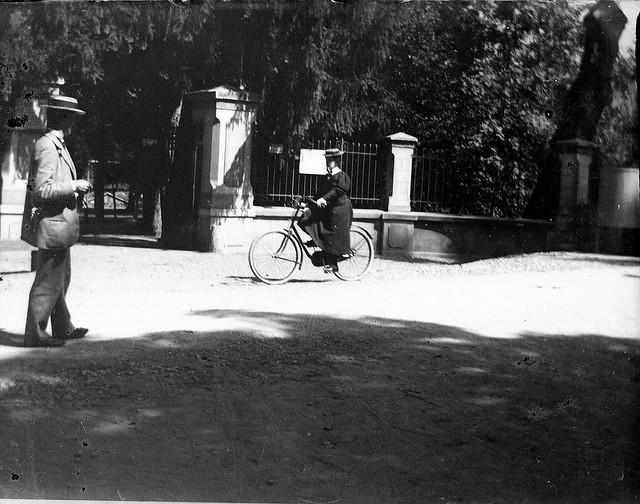Is the weather cold?
Write a very short answer. No. What piece of clothing are the two people wearing that is similar in style and color?
Quick response, please. Hat. What  is the man in black riding?
Write a very short answer. Bicycle. What kind of vehicle is shown?
Short answer required. Bicycle. Has the picture been taken recently?
Quick response, please. No. 